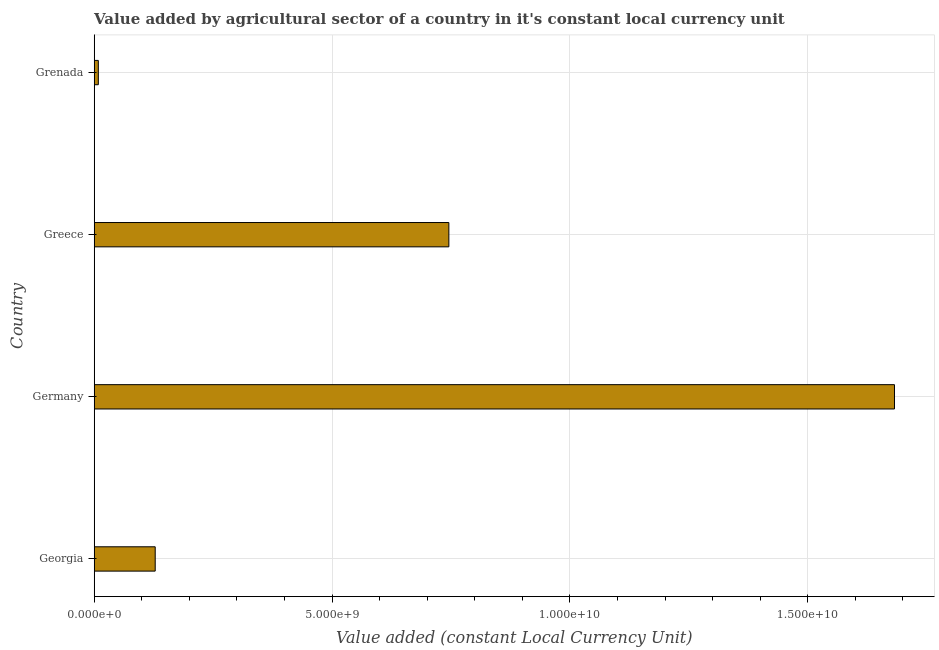Does the graph contain any zero values?
Keep it short and to the point. No. Does the graph contain grids?
Offer a terse response. Yes. What is the title of the graph?
Offer a terse response. Value added by agricultural sector of a country in it's constant local currency unit. What is the label or title of the X-axis?
Your answer should be compact. Value added (constant Local Currency Unit). What is the value added by agriculture sector in Greece?
Offer a terse response. 7.45e+09. Across all countries, what is the maximum value added by agriculture sector?
Provide a short and direct response. 1.68e+1. Across all countries, what is the minimum value added by agriculture sector?
Your response must be concise. 8.68e+07. In which country was the value added by agriculture sector maximum?
Provide a short and direct response. Germany. In which country was the value added by agriculture sector minimum?
Make the answer very short. Grenada. What is the sum of the value added by agriculture sector?
Keep it short and to the point. 2.56e+1. What is the difference between the value added by agriculture sector in Greece and Grenada?
Provide a short and direct response. 7.37e+09. What is the average value added by agriculture sector per country?
Keep it short and to the point. 6.41e+09. What is the median value added by agriculture sector?
Give a very brief answer. 4.37e+09. In how many countries, is the value added by agriculture sector greater than 1000000000 LCU?
Make the answer very short. 3. What is the ratio of the value added by agriculture sector in Germany to that in Grenada?
Offer a very short reply. 193.82. Is the value added by agriculture sector in Germany less than that in Greece?
Provide a succinct answer. No. What is the difference between the highest and the second highest value added by agriculture sector?
Provide a short and direct response. 9.37e+09. What is the difference between the highest and the lowest value added by agriculture sector?
Your answer should be very brief. 1.67e+1. Are all the bars in the graph horizontal?
Your answer should be very brief. Yes. What is the difference between two consecutive major ticks on the X-axis?
Your answer should be compact. 5.00e+09. What is the Value added (constant Local Currency Unit) in Georgia?
Make the answer very short. 1.28e+09. What is the Value added (constant Local Currency Unit) in Germany?
Give a very brief answer. 1.68e+1. What is the Value added (constant Local Currency Unit) of Greece?
Your response must be concise. 7.45e+09. What is the Value added (constant Local Currency Unit) in Grenada?
Give a very brief answer. 8.68e+07. What is the difference between the Value added (constant Local Currency Unit) in Georgia and Germany?
Provide a succinct answer. -1.55e+1. What is the difference between the Value added (constant Local Currency Unit) in Georgia and Greece?
Keep it short and to the point. -6.17e+09. What is the difference between the Value added (constant Local Currency Unit) in Georgia and Grenada?
Your answer should be very brief. 1.20e+09. What is the difference between the Value added (constant Local Currency Unit) in Germany and Greece?
Your response must be concise. 9.37e+09. What is the difference between the Value added (constant Local Currency Unit) in Germany and Grenada?
Ensure brevity in your answer.  1.67e+1. What is the difference between the Value added (constant Local Currency Unit) in Greece and Grenada?
Offer a terse response. 7.37e+09. What is the ratio of the Value added (constant Local Currency Unit) in Georgia to that in Germany?
Offer a terse response. 0.08. What is the ratio of the Value added (constant Local Currency Unit) in Georgia to that in Greece?
Your response must be concise. 0.17. What is the ratio of the Value added (constant Local Currency Unit) in Georgia to that in Grenada?
Your response must be concise. 14.78. What is the ratio of the Value added (constant Local Currency Unit) in Germany to that in Greece?
Provide a short and direct response. 2.26. What is the ratio of the Value added (constant Local Currency Unit) in Germany to that in Grenada?
Provide a succinct answer. 193.82. What is the ratio of the Value added (constant Local Currency Unit) in Greece to that in Grenada?
Ensure brevity in your answer.  85.89. 